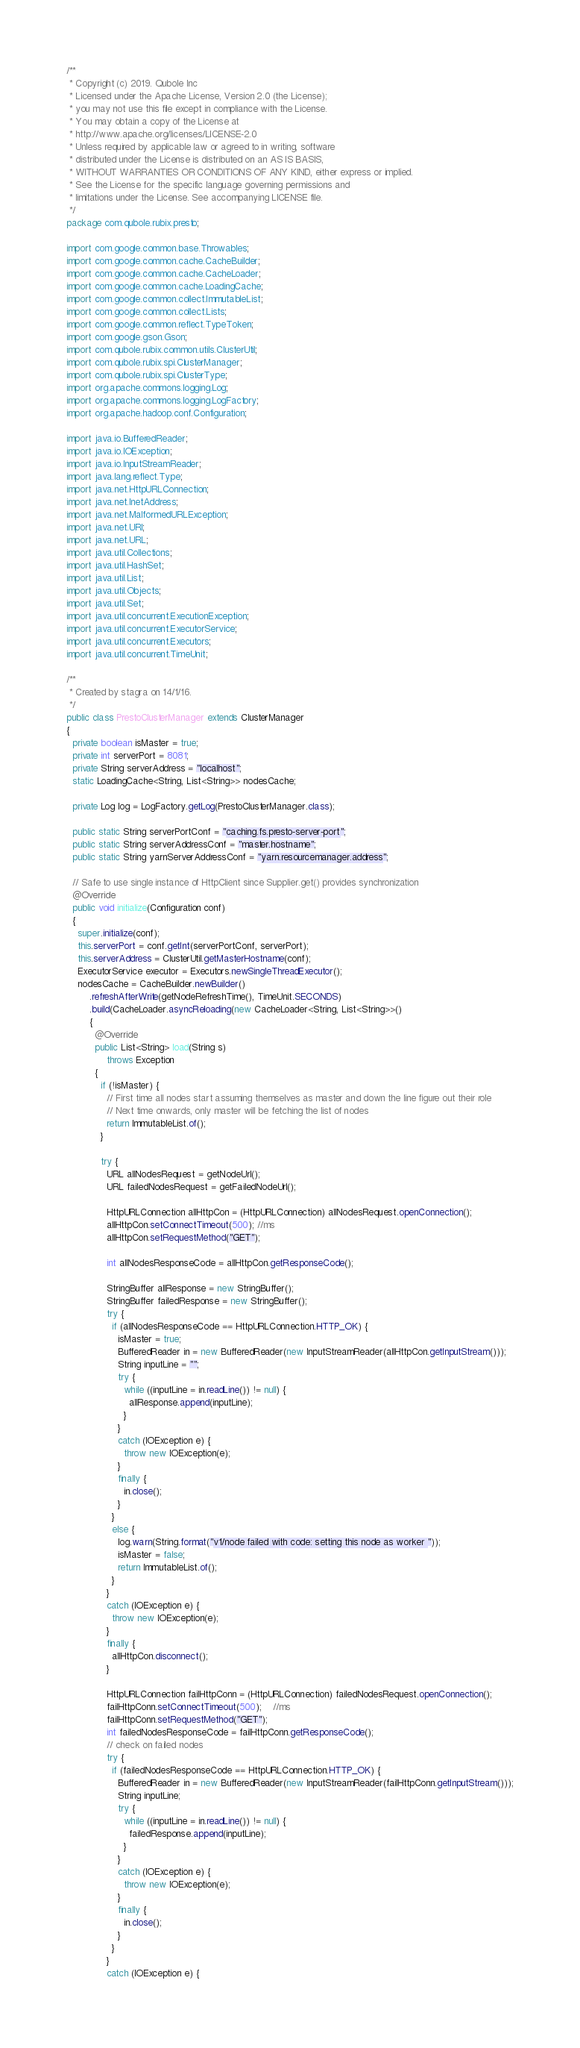Convert code to text. <code><loc_0><loc_0><loc_500><loc_500><_Java_>/**
 * Copyright (c) 2019. Qubole Inc
 * Licensed under the Apache License, Version 2.0 (the License);
 * you may not use this file except in compliance with the License.
 * You may obtain a copy of the License at
 * http://www.apache.org/licenses/LICENSE-2.0
 * Unless required by applicable law or agreed to in writing, software
 * distributed under the License is distributed on an AS IS BASIS,
 * WITHOUT WARRANTIES OR CONDITIONS OF ANY KIND, either express or implied.
 * See the License for the specific language governing permissions and
 * limitations under the License. See accompanying LICENSE file.
 */
package com.qubole.rubix.presto;

import com.google.common.base.Throwables;
import com.google.common.cache.CacheBuilder;
import com.google.common.cache.CacheLoader;
import com.google.common.cache.LoadingCache;
import com.google.common.collect.ImmutableList;
import com.google.common.collect.Lists;
import com.google.common.reflect.TypeToken;
import com.google.gson.Gson;
import com.qubole.rubix.common.utils.ClusterUtil;
import com.qubole.rubix.spi.ClusterManager;
import com.qubole.rubix.spi.ClusterType;
import org.apache.commons.logging.Log;
import org.apache.commons.logging.LogFactory;
import org.apache.hadoop.conf.Configuration;

import java.io.BufferedReader;
import java.io.IOException;
import java.io.InputStreamReader;
import java.lang.reflect.Type;
import java.net.HttpURLConnection;
import java.net.InetAddress;
import java.net.MalformedURLException;
import java.net.URI;
import java.net.URL;
import java.util.Collections;
import java.util.HashSet;
import java.util.List;
import java.util.Objects;
import java.util.Set;
import java.util.concurrent.ExecutionException;
import java.util.concurrent.ExecutorService;
import java.util.concurrent.Executors;
import java.util.concurrent.TimeUnit;

/**
 * Created by stagra on 14/1/16.
 */
public class PrestoClusterManager extends ClusterManager
{
  private boolean isMaster = true;
  private int serverPort = 8081;
  private String serverAddress = "localhost";
  static LoadingCache<String, List<String>> nodesCache;

  private Log log = LogFactory.getLog(PrestoClusterManager.class);

  public static String serverPortConf = "caching.fs.presto-server-port";
  public static String serverAddressConf = "master.hostname";
  public static String yarnServerAddressConf = "yarn.resourcemanager.address";

  // Safe to use single instance of HttpClient since Supplier.get() provides synchronization
  @Override
  public void initialize(Configuration conf)
  {
    super.initialize(conf);
    this.serverPort = conf.getInt(serverPortConf, serverPort);
    this.serverAddress = ClusterUtil.getMasterHostname(conf);
    ExecutorService executor = Executors.newSingleThreadExecutor();
    nodesCache = CacheBuilder.newBuilder()
        .refreshAfterWrite(getNodeRefreshTime(), TimeUnit.SECONDS)
        .build(CacheLoader.asyncReloading(new CacheLoader<String, List<String>>()
        {
          @Override
          public List<String> load(String s)
              throws Exception
          {
            if (!isMaster) {
              // First time all nodes start assuming themselves as master and down the line figure out their role
              // Next time onwards, only master will be fetching the list of nodes
              return ImmutableList.of();
            }

            try {
              URL allNodesRequest = getNodeUrl();
              URL failedNodesRequest = getFailedNodeUrl();

              HttpURLConnection allHttpCon = (HttpURLConnection) allNodesRequest.openConnection();
              allHttpCon.setConnectTimeout(500); //ms
              allHttpCon.setRequestMethod("GET");

              int allNodesResponseCode = allHttpCon.getResponseCode();

              StringBuffer allResponse = new StringBuffer();
              StringBuffer failedResponse = new StringBuffer();
              try {
                if (allNodesResponseCode == HttpURLConnection.HTTP_OK) {
                  isMaster = true;
                  BufferedReader in = new BufferedReader(new InputStreamReader(allHttpCon.getInputStream()));
                  String inputLine = "";
                  try {
                    while ((inputLine = in.readLine()) != null) {
                      allResponse.append(inputLine);
                    }
                  }
                  catch (IOException e) {
                    throw new IOException(e);
                  }
                  finally {
                    in.close();
                  }
                }
                else {
                  log.warn(String.format("v1/node failed with code: setting this node as worker "));
                  isMaster = false;
                  return ImmutableList.of();
                }
              }
              catch (IOException e) {
                throw new IOException(e);
              }
              finally {
                allHttpCon.disconnect();
              }

              HttpURLConnection failHttpConn = (HttpURLConnection) failedNodesRequest.openConnection();
              failHttpConn.setConnectTimeout(500);    //ms
              failHttpConn.setRequestMethod("GET");
              int failedNodesResponseCode = failHttpConn.getResponseCode();
              // check on failed nodes
              try {
                if (failedNodesResponseCode == HttpURLConnection.HTTP_OK) {
                  BufferedReader in = new BufferedReader(new InputStreamReader(failHttpConn.getInputStream()));
                  String inputLine;
                  try {
                    while ((inputLine = in.readLine()) != null) {
                      failedResponse.append(inputLine);
                    }
                  }
                  catch (IOException e) {
                    throw new IOException(e);
                  }
                  finally {
                    in.close();
                  }
                }
              }
              catch (IOException e) {</code> 